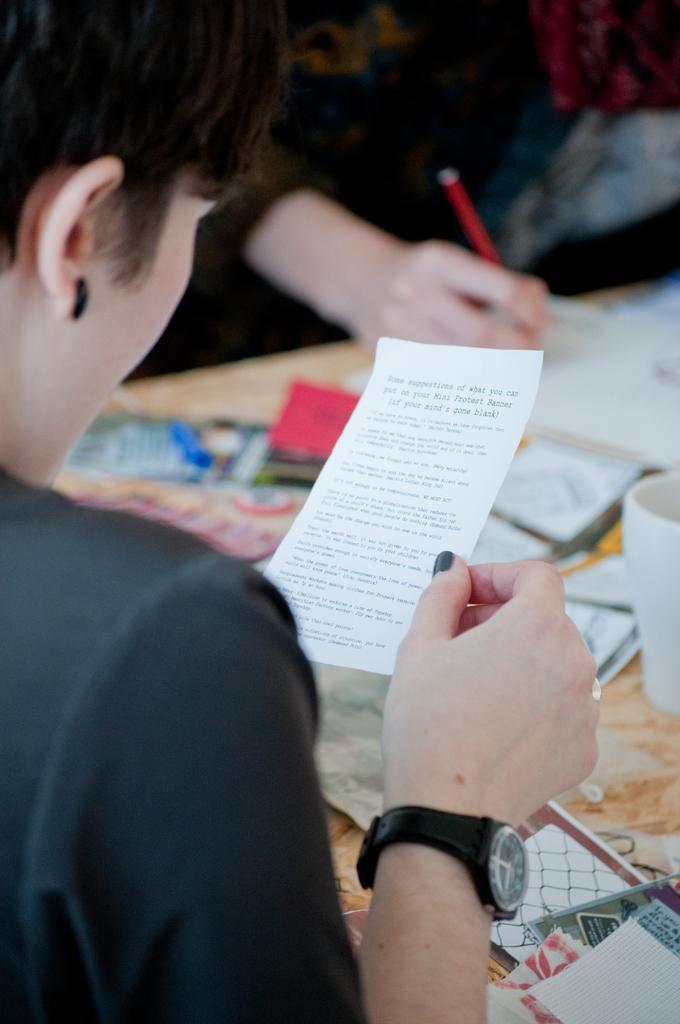Please provide a concise description of this image. In this picture we can see people and table. One person is holding a paper. Another person is holding a pen. On the table there is a mug and things. 